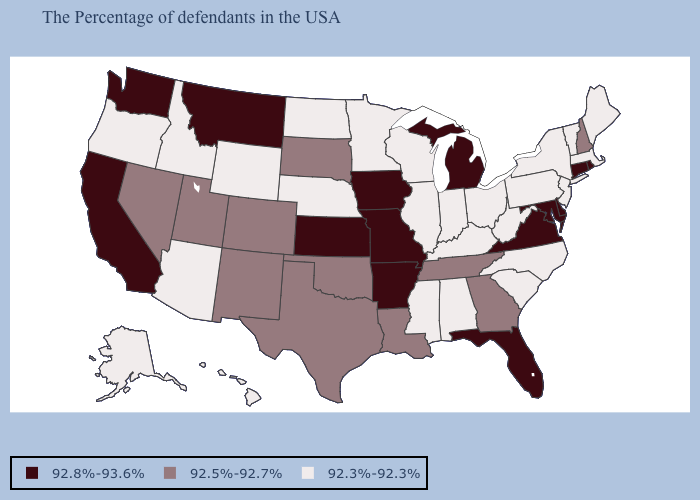What is the value of New Mexico?
Keep it brief. 92.5%-92.7%. Name the states that have a value in the range 92.8%-93.6%?
Write a very short answer. Rhode Island, Connecticut, Delaware, Maryland, Virginia, Florida, Michigan, Missouri, Arkansas, Iowa, Kansas, Montana, California, Washington. Which states have the lowest value in the West?
Quick response, please. Wyoming, Arizona, Idaho, Oregon, Alaska, Hawaii. Name the states that have a value in the range 92.8%-93.6%?
Write a very short answer. Rhode Island, Connecticut, Delaware, Maryland, Virginia, Florida, Michigan, Missouri, Arkansas, Iowa, Kansas, Montana, California, Washington. Name the states that have a value in the range 92.8%-93.6%?
Short answer required. Rhode Island, Connecticut, Delaware, Maryland, Virginia, Florida, Michigan, Missouri, Arkansas, Iowa, Kansas, Montana, California, Washington. Does the first symbol in the legend represent the smallest category?
Keep it brief. No. What is the lowest value in states that border Oklahoma?
Concise answer only. 92.5%-92.7%. Name the states that have a value in the range 92.8%-93.6%?
Concise answer only. Rhode Island, Connecticut, Delaware, Maryland, Virginia, Florida, Michigan, Missouri, Arkansas, Iowa, Kansas, Montana, California, Washington. Name the states that have a value in the range 92.8%-93.6%?
Answer briefly. Rhode Island, Connecticut, Delaware, Maryland, Virginia, Florida, Michigan, Missouri, Arkansas, Iowa, Kansas, Montana, California, Washington. What is the highest value in the USA?
Keep it brief. 92.8%-93.6%. Which states have the lowest value in the MidWest?
Short answer required. Ohio, Indiana, Wisconsin, Illinois, Minnesota, Nebraska, North Dakota. Name the states that have a value in the range 92.8%-93.6%?
Short answer required. Rhode Island, Connecticut, Delaware, Maryland, Virginia, Florida, Michigan, Missouri, Arkansas, Iowa, Kansas, Montana, California, Washington. Among the states that border Virginia , which have the highest value?
Give a very brief answer. Maryland. Among the states that border Minnesota , which have the lowest value?
Keep it brief. Wisconsin, North Dakota. 